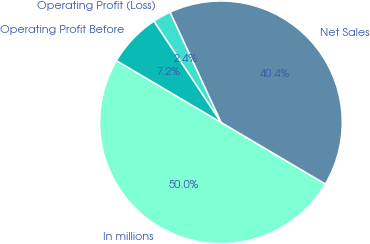<chart> <loc_0><loc_0><loc_500><loc_500><pie_chart><fcel>In millions<fcel>Net Sales<fcel>Operating Profit (Loss)<fcel>Operating Profit Before<nl><fcel>50.0%<fcel>40.38%<fcel>2.43%<fcel>7.19%<nl></chart> 